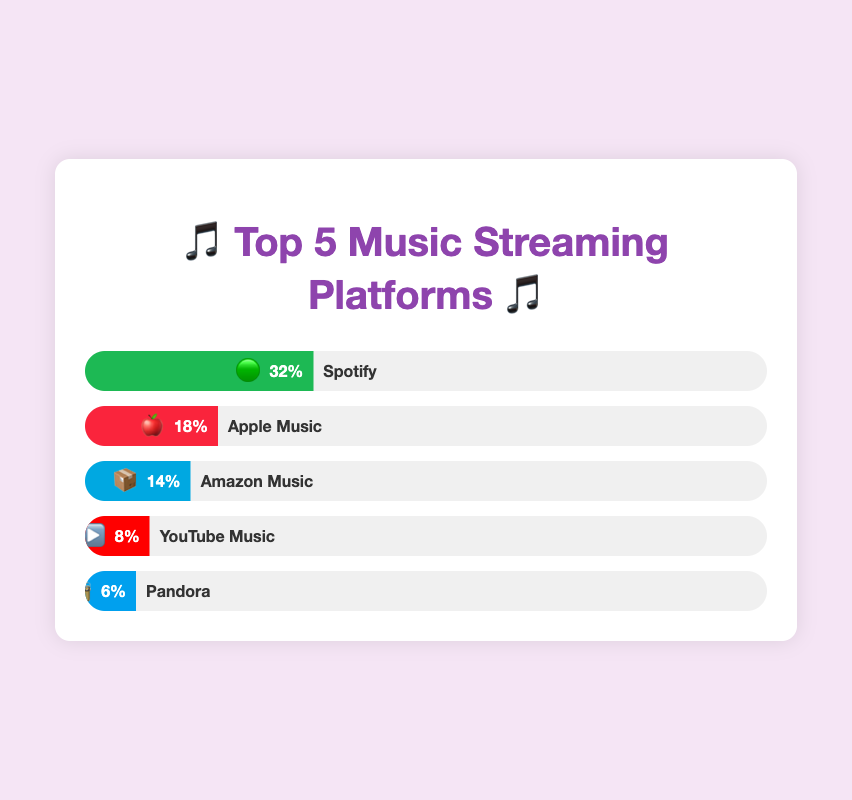What's the top streaming platform by market share? The bar filled with the highest percentage indicates the top platform. The green bar with 🟢 represents Spotify with a 32% market share.
Answer: Spotify What's the market share of Pandora? The bar for Pandora is filled to 6%, as indicated by the 📻 emoji and the number next to the bar.
Answer: 6% Which platform has a higher market share: Apple Music or Amazon Music? The red bar with 🍎 represents Apple Music at 18%, while the blue bar with 📦 represents Amazon Music at 14%. Apple Music has a higher market share.
Answer: Apple Music What is the combined market share of the top two streaming platforms? The top two platforms are Spotify (32%) and Apple Music (18%). Summing up their market shares gives 32% + 18% = 50%.
Answer: 50% How much more market share does Spotify have compared to YouTube Music? Spotify has a 32% market share, while YouTube Music has 8%. The difference is 32% - 8% = 24%.
Answer: 24% Which platform has the smallest market share among the top 5? The bar with the smallest width is for Pandora (📻), which has a 6% market share.
Answer: Pandora Out of the top 5 platforms, how many have a market share below 10%? YouTube Music (8%) and Pandora (6%) each have a market share below 10%, so there are 2 platforms.
Answer: 2 What is the average market share of Apple Music and Amazon Music? Apple Music has an 18% share and Amazon Music has 14%. The average is calculated as (18% + 14%) / 2 = 16%.
Answer: 16% 